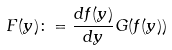<formula> <loc_0><loc_0><loc_500><loc_500>F ( y ) \colon = \frac { d f ( y ) } { d y } G ( f ( y ) )</formula> 